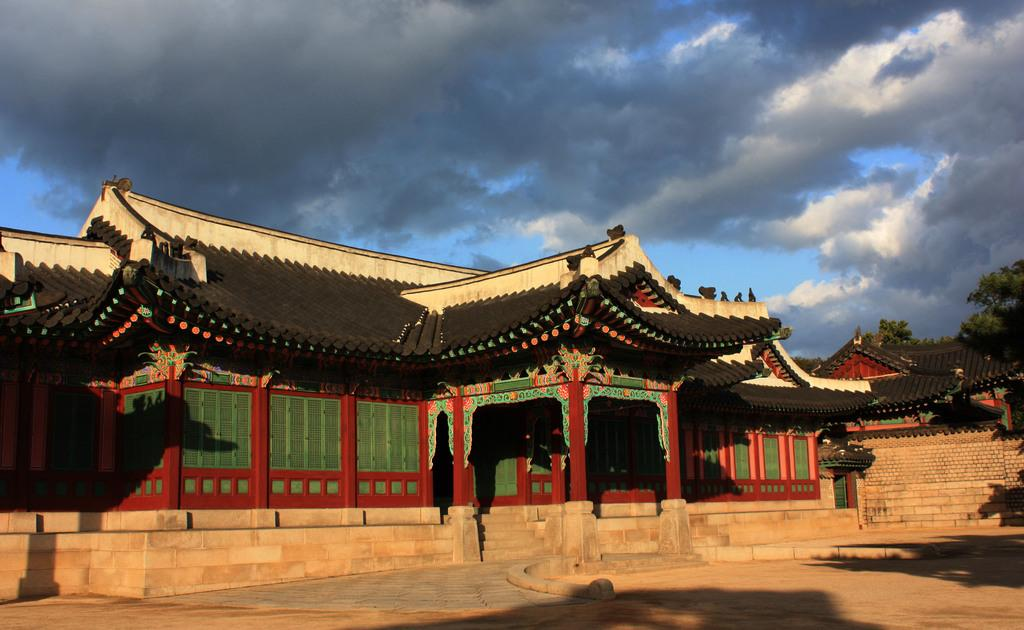What type of structures can be seen in the image? There are houses in the image. What is located near the houses? There is a wall in the image. What can be seen in the background of the image? There are trees and the sky visible in the background of the image. What is the condition of the sky in the image? Clouds are present in the sky. How does the crowd interact with the silver attention in the image? There is no crowd or silver attention present in the image. 